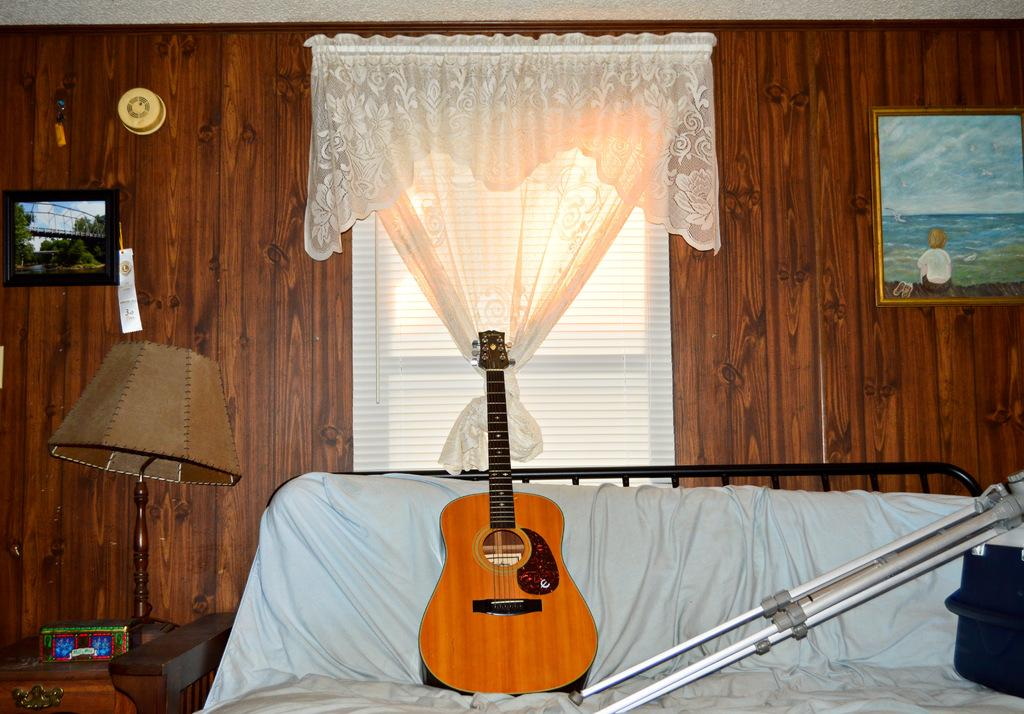What musical instrument is present in the image? There is a guitar in the image. What is the guitar resting on in the image? The guitar is resting on a stand on the sofa. What can be seen in the background of the image? There is a light, a curtain, and wall paintings in the background. What type of bottle is placed on the guitar in the image? There is no bottle present on the guitar in the image. 